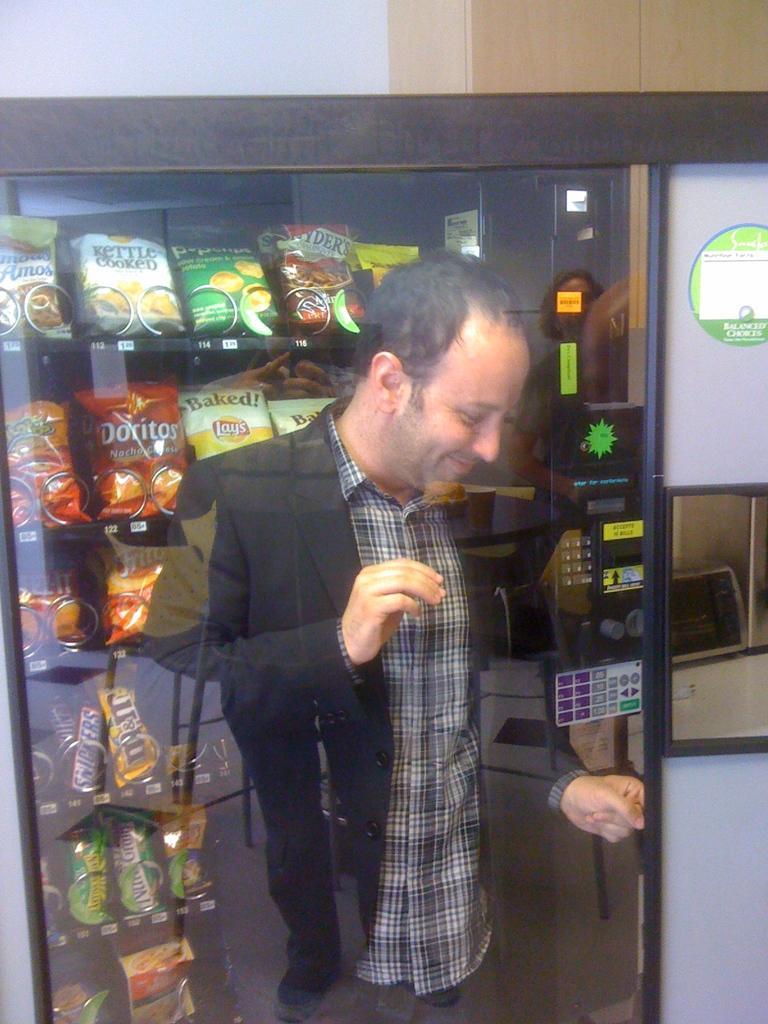In one or two sentences, can you explain what this image depicts? Here we can see glass,behind this glass there is a man standing and behind this man we can see packet and objects in racks. Background we can see wall. 